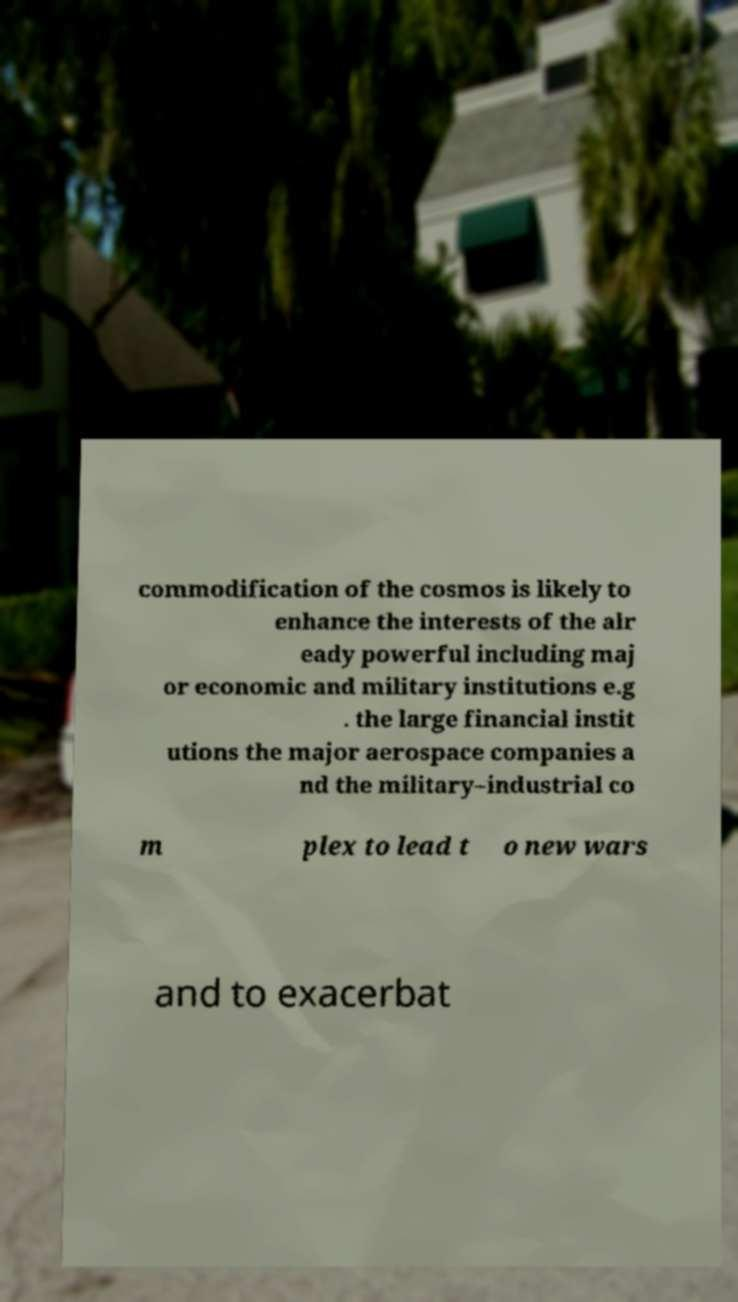There's text embedded in this image that I need extracted. Can you transcribe it verbatim? commodification of the cosmos is likely to enhance the interests of the alr eady powerful including maj or economic and military institutions e.g . the large financial instit utions the major aerospace companies a nd the military–industrial co m plex to lead t o new wars and to exacerbat 